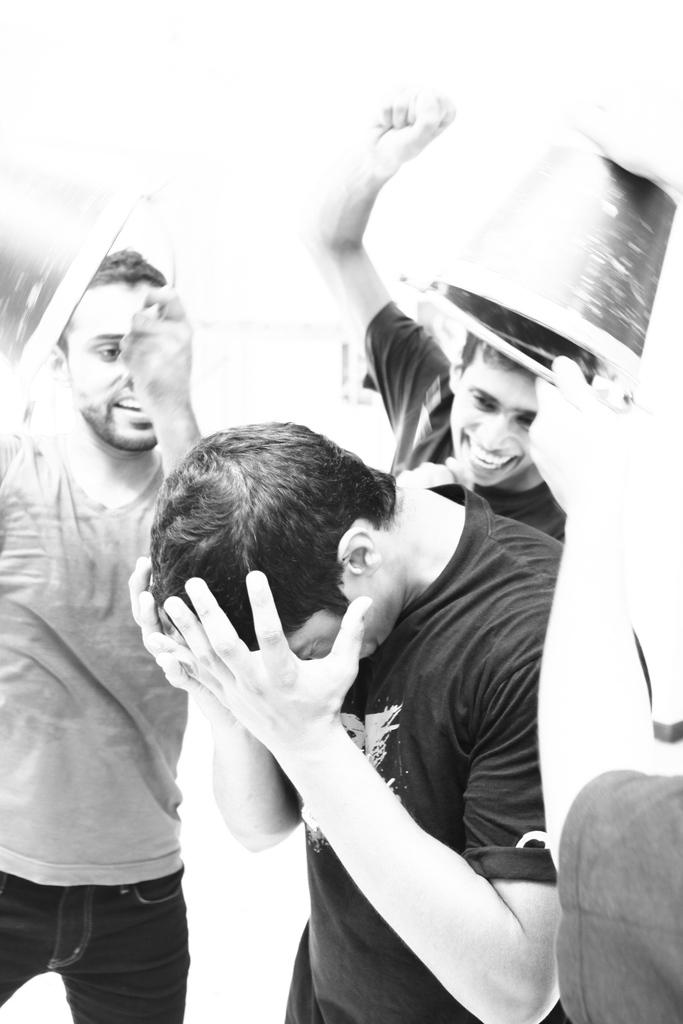What is the color scheme of the image? The image is black and white. What can be seen in the image? There are persons in the image. Can you describe the background of the image? The background of the image is blurred. What type of air can be seen in the image? There is no air visible in the image, as it is a black and white photograph. Is there a doll present in the image? No, there is no doll present in the image; it features persons and a blurred background. 